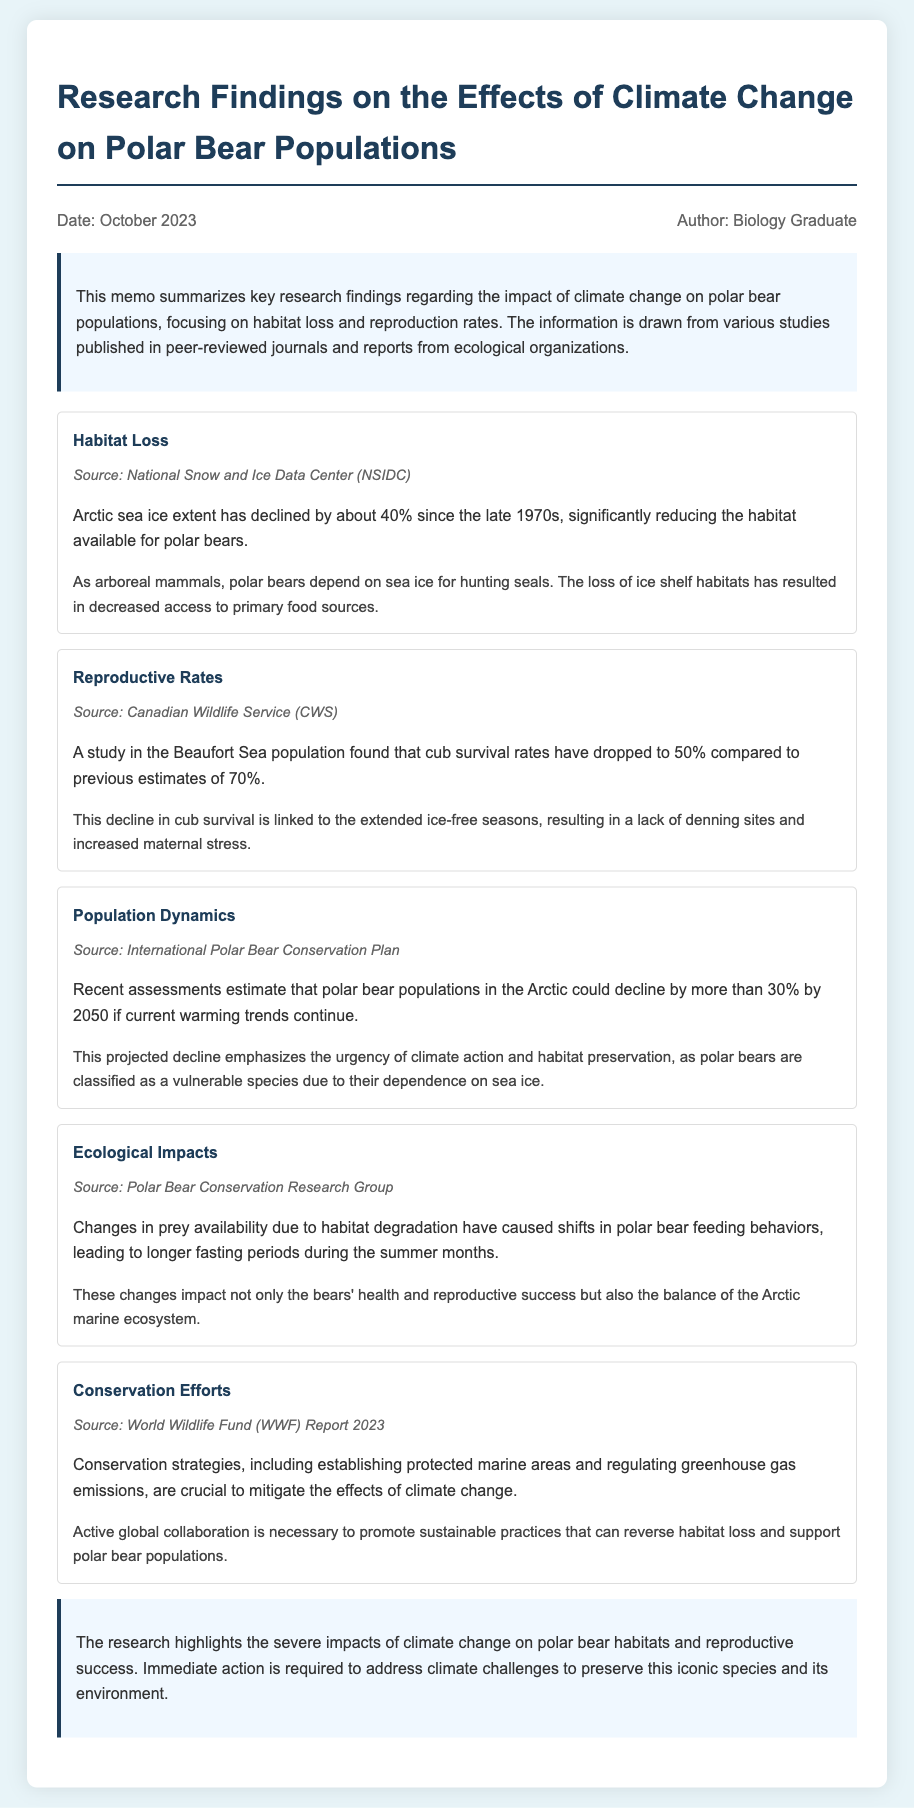What is the percentage decline in Arctic sea ice extent since the late 1970s? The document states that Arctic sea ice extent has declined by about 40% since the late 1970s.
Answer: 40% What is the cub survival rate in the Beaufort Sea population currently? A study indicates that cub survival rates have dropped to 50%, down from previous estimates of 70%.
Answer: 50% By what percentage could polar bear populations decline by 2050? Recent assessments estimate that polar bear populations could decline by more than 30% by 2050 if warming trends continue.
Answer: More than 30% What are the implications of extended ice-free seasons on polar bears? The extended ice-free seasons result in a lack of denning sites and increased maternal stress, affecting cub survival.
Answer: Lack of denning sites and increased maternal stress Which ecological organization provided the research on ecological impacts? The information regarding ecological impacts is from the Polar Bear Conservation Research Group.
Answer: Polar Bear Conservation Research Group What main conservation strategy is highlighted in the findings? One crucial conservation strategy mentioned is establishing protected marine areas and regulating greenhouse gas emissions.
Answer: Protected marine areas and regulating greenhouse gas emissions What is the document's publication date? The memo indicates the publication date is October 2023.
Answer: October 2023 Who is the author of the memo? The author of the memo is identified as a Biology Graduate.
Answer: Biology Graduate 